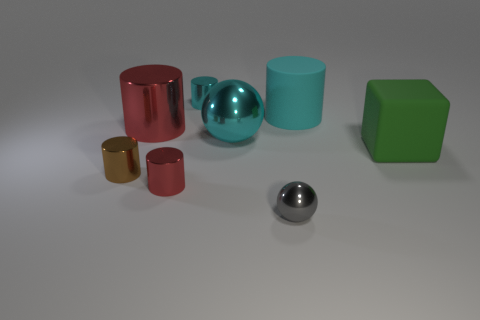Subtract all brown cylinders. How many cylinders are left? 4 Subtract all big red shiny cylinders. How many cylinders are left? 4 Subtract all yellow cylinders. Subtract all cyan cubes. How many cylinders are left? 5 Add 1 large red things. How many objects exist? 9 Subtract all cylinders. How many objects are left? 3 Subtract all big cyan rubber cylinders. Subtract all cyan balls. How many objects are left? 6 Add 2 brown objects. How many brown objects are left? 3 Add 1 green metallic blocks. How many green metallic blocks exist? 1 Subtract 0 yellow cylinders. How many objects are left? 8 